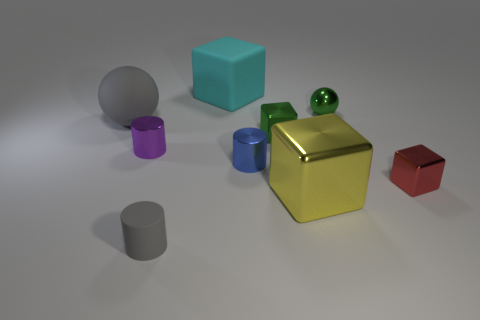How many objects are cyan blocks or small yellow metallic blocks?
Offer a very short reply. 1. There is a metal thing to the left of the gray cylinder; does it have the same color as the cylinder that is to the right of the small gray rubber object?
Offer a terse response. No. What number of other things are there of the same shape as the large yellow shiny thing?
Make the answer very short. 3. Is there a tiny gray cylinder?
Make the answer very short. Yes. How many objects are either gray shiny things or small things to the right of the large cyan cube?
Provide a short and direct response. 4. Is the size of the ball that is left of the shiny sphere the same as the green block?
Keep it short and to the point. No. What number of other objects are there of the same size as the purple metal thing?
Offer a terse response. 5. The rubber block has what color?
Ensure brevity in your answer.  Cyan. What material is the gray object behind the large shiny block?
Ensure brevity in your answer.  Rubber. Are there the same number of purple cylinders behind the green metal sphere and tiny blue cylinders?
Provide a succinct answer. No. 